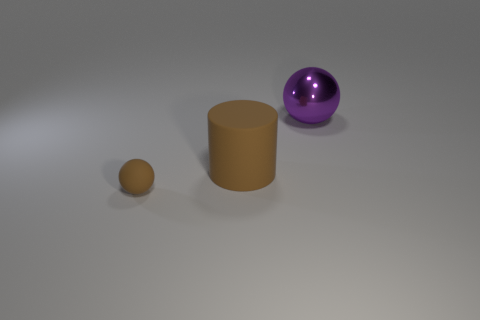Subtract all spheres. How many objects are left? 1 Add 1 green blocks. How many objects exist? 4 Add 3 big brown cylinders. How many big brown cylinders are left? 4 Add 2 large red cylinders. How many large red cylinders exist? 2 Subtract 0 red cylinders. How many objects are left? 3 Subtract all brown shiny cylinders. Subtract all big purple things. How many objects are left? 2 